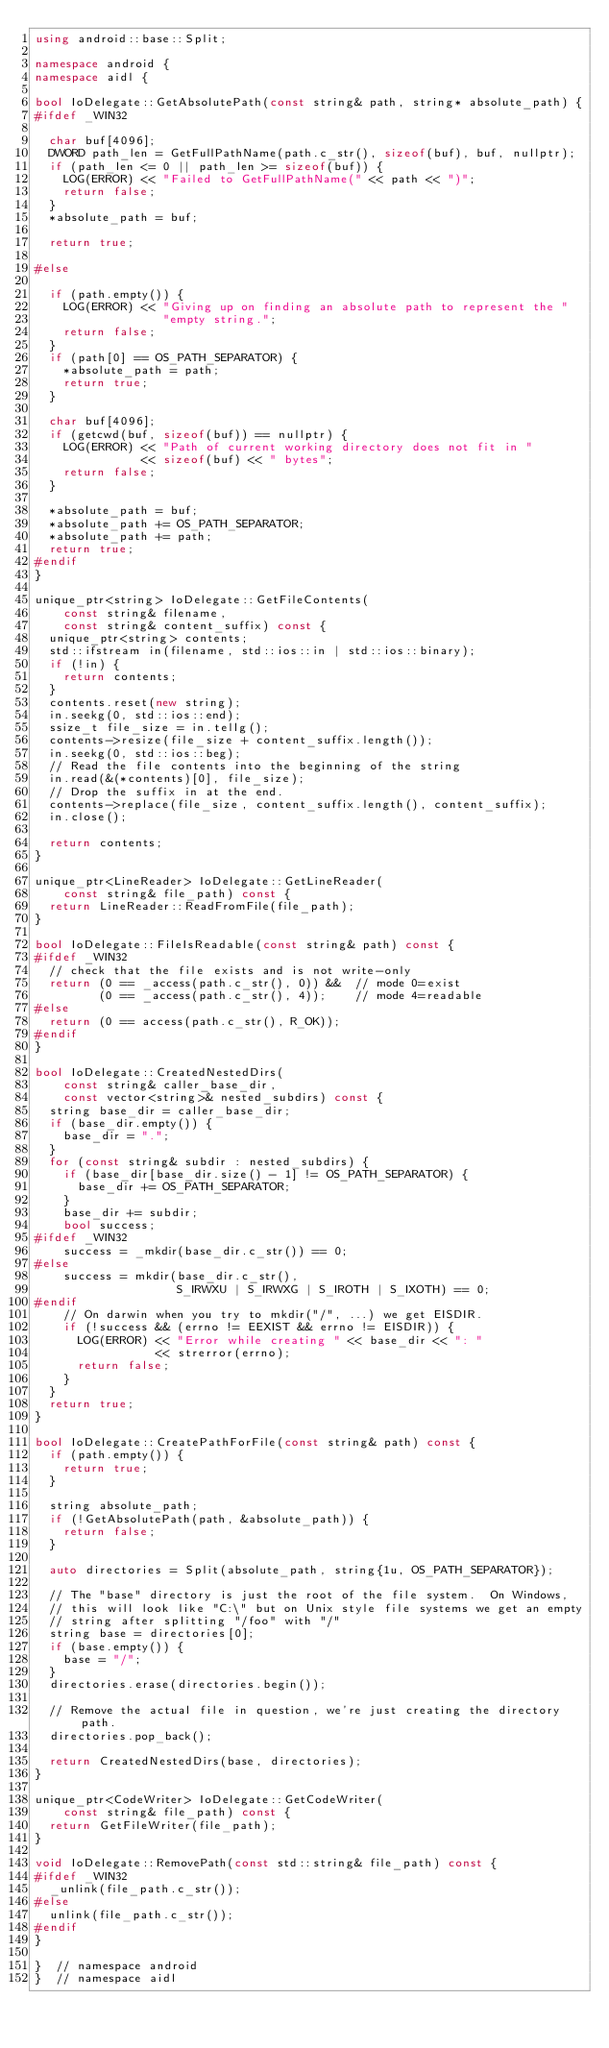Convert code to text. <code><loc_0><loc_0><loc_500><loc_500><_C++_>using android::base::Split;

namespace android {
namespace aidl {

bool IoDelegate::GetAbsolutePath(const string& path, string* absolute_path) {
#ifdef _WIN32

  char buf[4096];
  DWORD path_len = GetFullPathName(path.c_str(), sizeof(buf), buf, nullptr);
  if (path_len <= 0 || path_len >= sizeof(buf)) {
    LOG(ERROR) << "Failed to GetFullPathName(" << path << ")";
    return false;
  }
  *absolute_path = buf;

  return true;

#else

  if (path.empty()) {
    LOG(ERROR) << "Giving up on finding an absolute path to represent the "
                  "empty string.";
    return false;
  }
  if (path[0] == OS_PATH_SEPARATOR) {
    *absolute_path = path;
    return true;
  }

  char buf[4096];
  if (getcwd(buf, sizeof(buf)) == nullptr) {
    LOG(ERROR) << "Path of current working directory does not fit in "
               << sizeof(buf) << " bytes";
    return false;
  }

  *absolute_path = buf;
  *absolute_path += OS_PATH_SEPARATOR;
  *absolute_path += path;
  return true;
#endif
}

unique_ptr<string> IoDelegate::GetFileContents(
    const string& filename,
    const string& content_suffix) const {
  unique_ptr<string> contents;
  std::ifstream in(filename, std::ios::in | std::ios::binary);
  if (!in) {
    return contents;
  }
  contents.reset(new string);
  in.seekg(0, std::ios::end);
  ssize_t file_size = in.tellg();
  contents->resize(file_size + content_suffix.length());
  in.seekg(0, std::ios::beg);
  // Read the file contents into the beginning of the string
  in.read(&(*contents)[0], file_size);
  // Drop the suffix in at the end.
  contents->replace(file_size, content_suffix.length(), content_suffix);
  in.close();

  return contents;
}

unique_ptr<LineReader> IoDelegate::GetLineReader(
    const string& file_path) const {
  return LineReader::ReadFromFile(file_path);
}

bool IoDelegate::FileIsReadable(const string& path) const {
#ifdef _WIN32
  // check that the file exists and is not write-only
  return (0 == _access(path.c_str(), 0)) &&  // mode 0=exist
         (0 == _access(path.c_str(), 4));    // mode 4=readable
#else
  return (0 == access(path.c_str(), R_OK));
#endif
}

bool IoDelegate::CreatedNestedDirs(
    const string& caller_base_dir,
    const vector<string>& nested_subdirs) const {
  string base_dir = caller_base_dir;
  if (base_dir.empty()) {
    base_dir = ".";
  }
  for (const string& subdir : nested_subdirs) {
    if (base_dir[base_dir.size() - 1] != OS_PATH_SEPARATOR) {
      base_dir += OS_PATH_SEPARATOR;
    }
    base_dir += subdir;
    bool success;
#ifdef _WIN32
    success = _mkdir(base_dir.c_str()) == 0;
#else
    success = mkdir(base_dir.c_str(),
                    S_IRWXU | S_IRWXG | S_IROTH | S_IXOTH) == 0;
#endif
    // On darwin when you try to mkdir("/", ...) we get EISDIR.
    if (!success && (errno != EEXIST && errno != EISDIR)) {
      LOG(ERROR) << "Error while creating " << base_dir << ": "
                 << strerror(errno);
      return false;
    }
  }
  return true;
}

bool IoDelegate::CreatePathForFile(const string& path) const {
  if (path.empty()) {
    return true;
  }

  string absolute_path;
  if (!GetAbsolutePath(path, &absolute_path)) {
    return false;
  }

  auto directories = Split(absolute_path, string{1u, OS_PATH_SEPARATOR});

  // The "base" directory is just the root of the file system.  On Windows,
  // this will look like "C:\" but on Unix style file systems we get an empty
  // string after splitting "/foo" with "/"
  string base = directories[0];
  if (base.empty()) {
    base = "/";
  }
  directories.erase(directories.begin());

  // Remove the actual file in question, we're just creating the directory path.
  directories.pop_back();

  return CreatedNestedDirs(base, directories);
}

unique_ptr<CodeWriter> IoDelegate::GetCodeWriter(
    const string& file_path) const {
  return GetFileWriter(file_path);
}

void IoDelegate::RemovePath(const std::string& file_path) const {
#ifdef _WIN32
  _unlink(file_path.c_str());
#else
  unlink(file_path.c_str());
#endif
}

}  // namespace android
}  // namespace aidl
</code> 